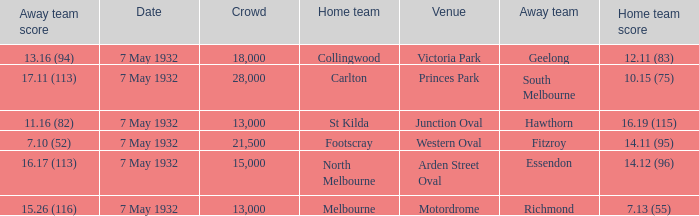What is the away team with a Crowd greater than 13,000, and a Home team score of 12.11 (83)? Geelong. 